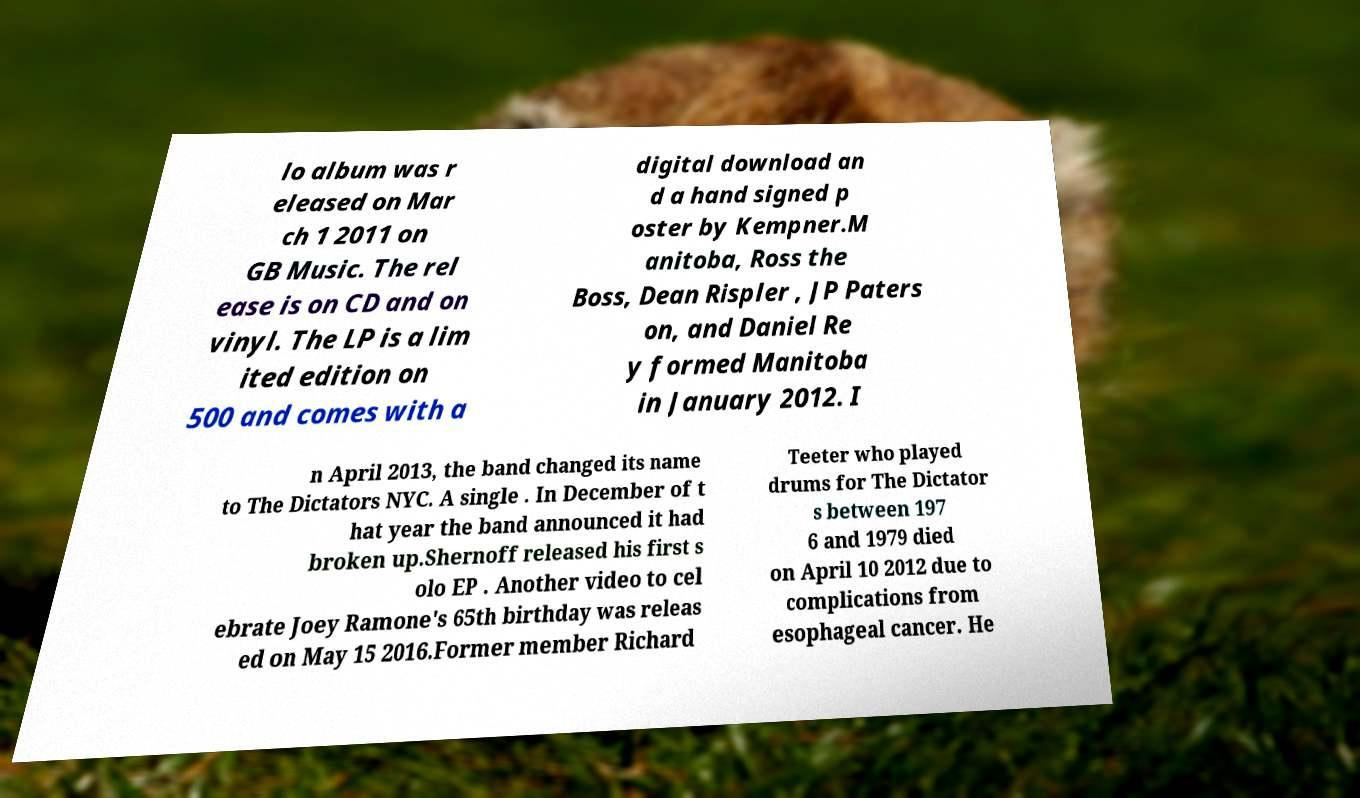Please read and relay the text visible in this image. What does it say? lo album was r eleased on Mar ch 1 2011 on GB Music. The rel ease is on CD and on vinyl. The LP is a lim ited edition on 500 and comes with a digital download an d a hand signed p oster by Kempner.M anitoba, Ross the Boss, Dean Rispler , JP Paters on, and Daniel Re y formed Manitoba in January 2012. I n April 2013, the band changed its name to The Dictators NYC. A single . In December of t hat year the band announced it had broken up.Shernoff released his first s olo EP . Another video to cel ebrate Joey Ramone's 65th birthday was releas ed on May 15 2016.Former member Richard Teeter who played drums for The Dictator s between 197 6 and 1979 died on April 10 2012 due to complications from esophageal cancer. He 